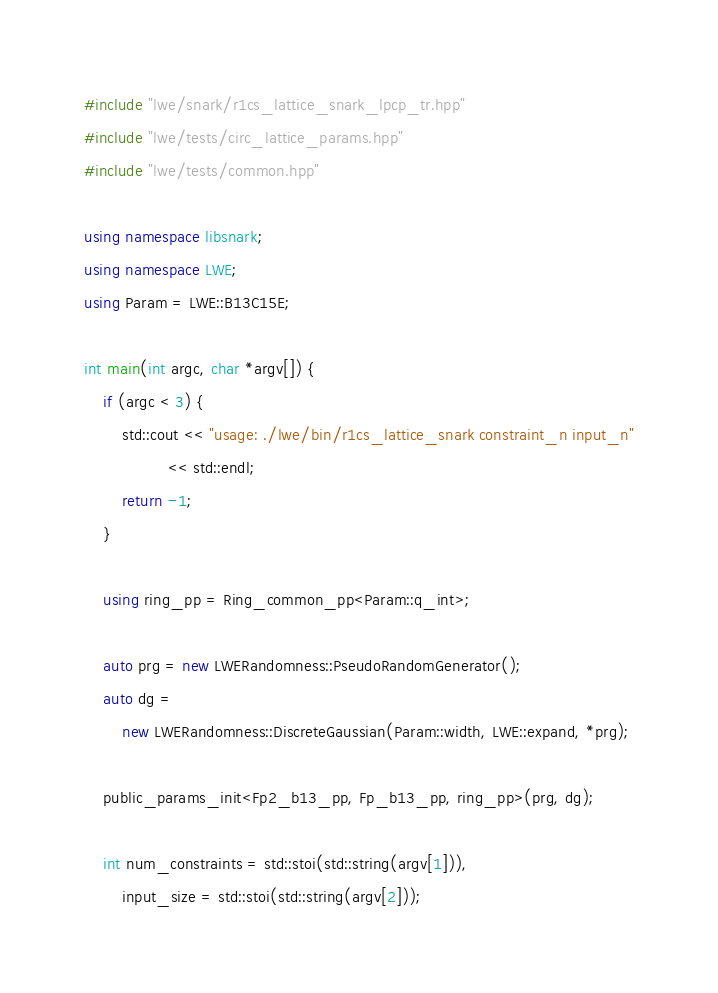Convert code to text. <code><loc_0><loc_0><loc_500><loc_500><_C++_>#include "lwe/snark/r1cs_lattice_snark_lpcp_tr.hpp"
#include "lwe/tests/circ_lattice_params.hpp"
#include "lwe/tests/common.hpp"

using namespace libsnark;
using namespace LWE;
using Param = LWE::B13C15E;

int main(int argc, char *argv[]) {
    if (argc < 3) {
        std::cout << "usage: ./lwe/bin/r1cs_lattice_snark constraint_n input_n"
                  << std::endl;
        return -1;
    }

    using ring_pp = Ring_common_pp<Param::q_int>;

    auto prg = new LWERandomness::PseudoRandomGenerator();
    auto dg =
        new LWERandomness::DiscreteGaussian(Param::width, LWE::expand, *prg);

    public_params_init<Fp2_b13_pp, Fp_b13_pp, ring_pp>(prg, dg);

    int num_constraints = std::stoi(std::string(argv[1])),
        input_size = std::stoi(std::string(argv[2]));
</code> 